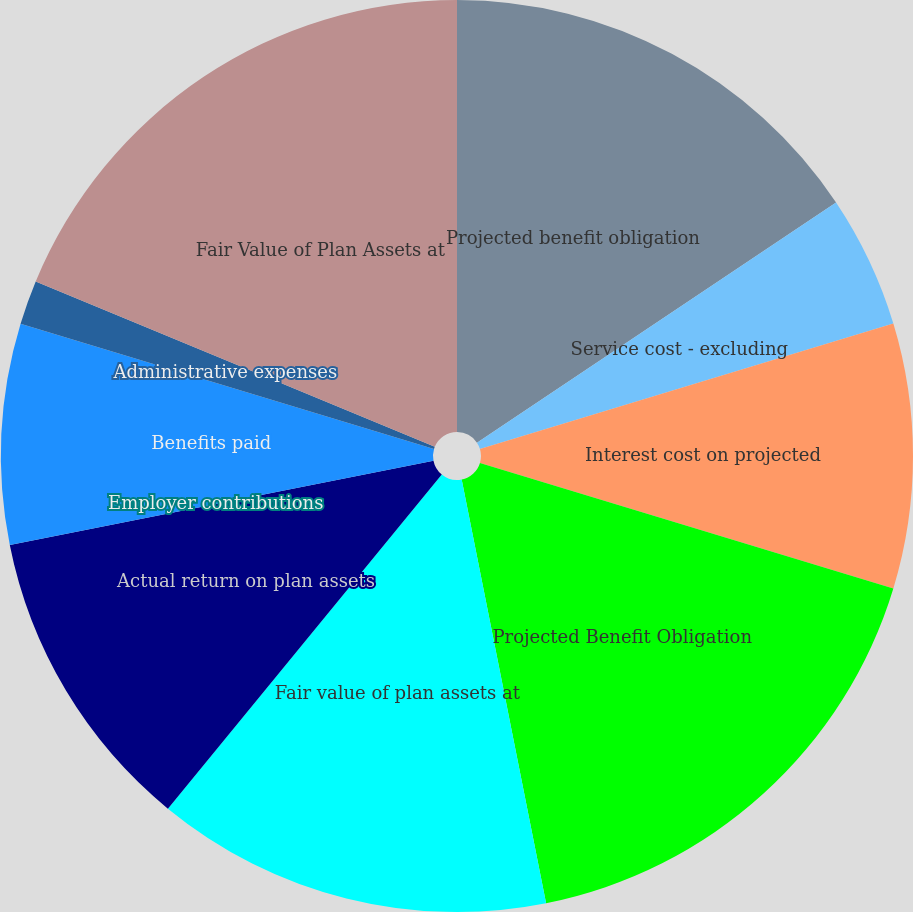Convert chart. <chart><loc_0><loc_0><loc_500><loc_500><pie_chart><fcel>Projected benefit obligation<fcel>Service cost - excluding<fcel>Interest cost on projected<fcel>Projected Benefit Obligation<fcel>Fair value of plan assets at<fcel>Actual return on plan assets<fcel>Employer contributions<fcel>Benefits paid<fcel>Administrative expenses<fcel>Fair Value of Plan Assets at<nl><fcel>15.62%<fcel>4.69%<fcel>9.38%<fcel>17.18%<fcel>14.06%<fcel>10.94%<fcel>0.0%<fcel>7.81%<fcel>1.57%<fcel>18.75%<nl></chart> 